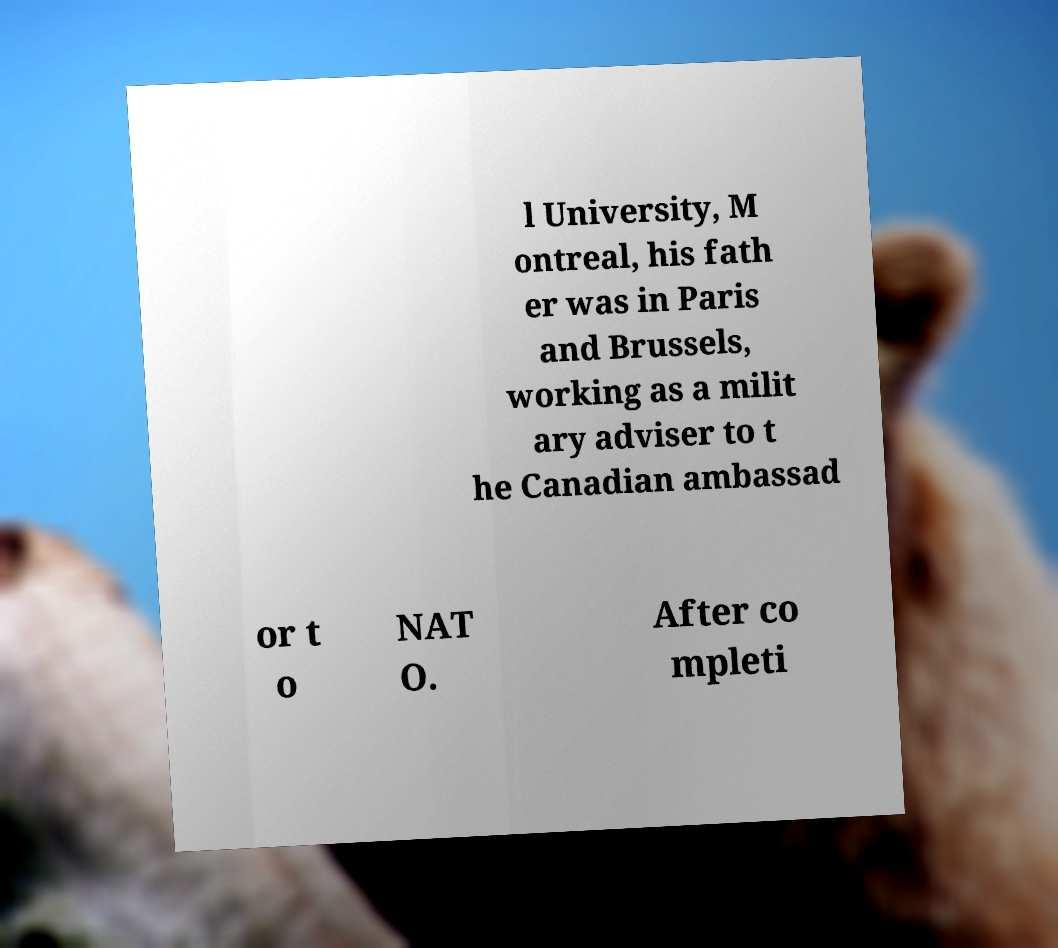Could you assist in decoding the text presented in this image and type it out clearly? l University, M ontreal, his fath er was in Paris and Brussels, working as a milit ary adviser to t he Canadian ambassad or t o NAT O. After co mpleti 